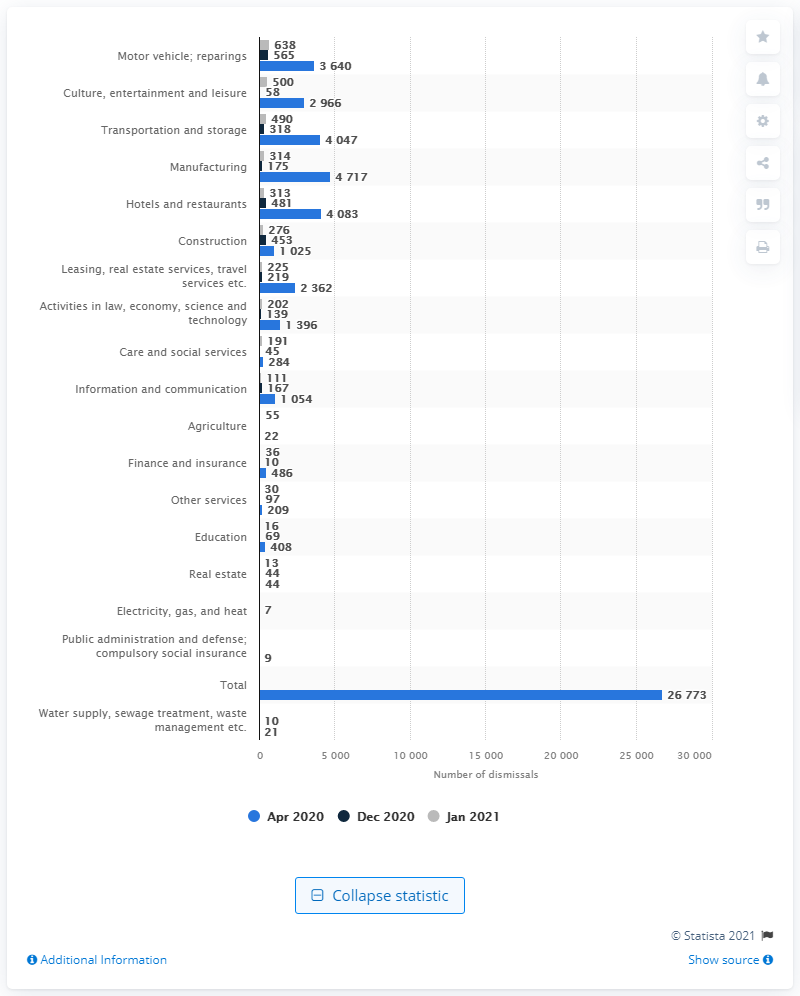Identify some key points in this picture. In April, a significant number of manufacturing workers lost their jobs, with a total of 4,717 individuals affected. In January 2021, a total of 314 people lost their jobs in the manufacturing industry. 